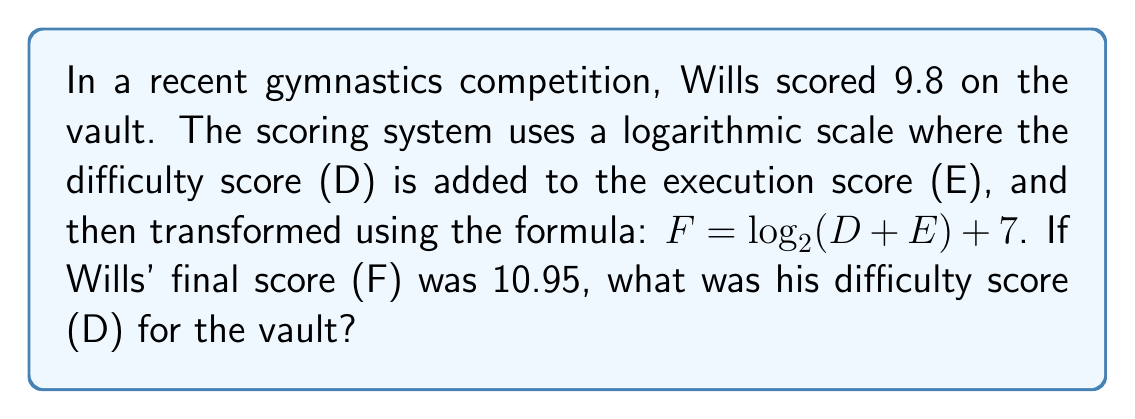Help me with this question. Let's approach this step-by-step:

1) We're given that the final score F is calculated using:
   $F = \log_2(D + E) + 7$

2) We know that:
   F = 10.95
   E = 9.8 (execution score)
   We need to find D (difficulty score)

3) Let's substitute the known values into the equation:
   $10.95 = \log_2(D + 9.8) + 7$

4) Subtract 7 from both sides:
   $3.95 = \log_2(D + 9.8)$

5) To solve for D + 9.8, we need to apply 2 to the power of both sides:
   $2^{3.95} = D + 9.8$

6) Calculate $2^{3.95}$:
   $2^{3.95} \approx 15.4566$

7) Now we can solve for D:
   $15.4566 = D + 9.8$
   $D = 15.4566 - 9.8$
   $D \approx 5.6566$

8) Rounding to two decimal places (as is common in gymnastics scoring):
   $D \approx 5.66$
Answer: 5.66 